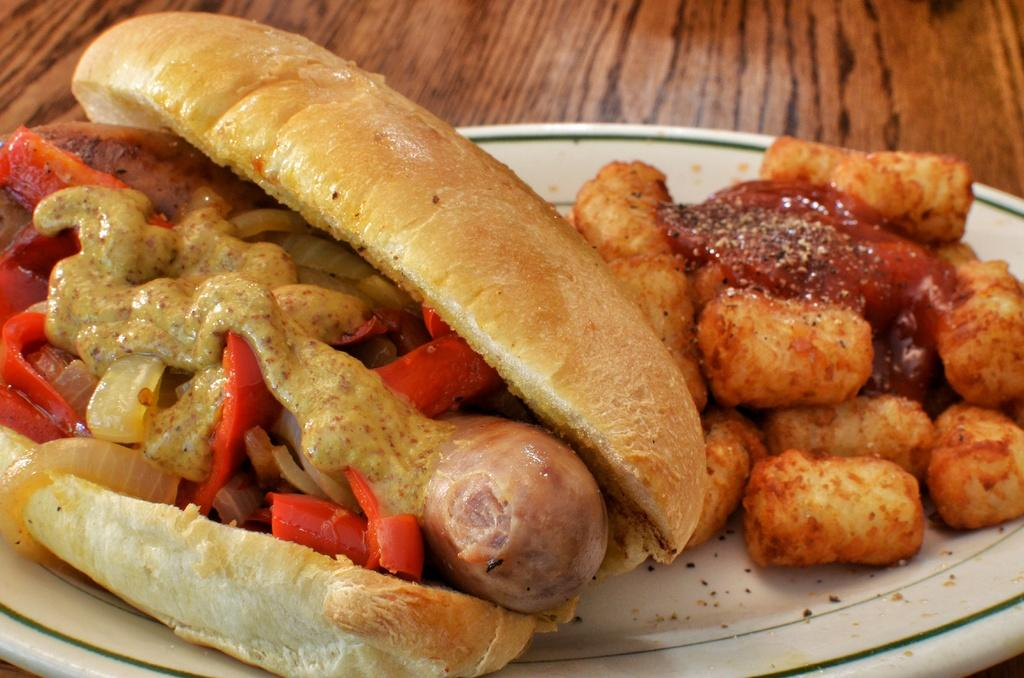What is the main object in the center of the image? There is a plate in the center of the image. What is on the plate? The plate contains food items. What nation is the actor from in the image? There is no actor present in the image, as it only features a plate with food items. 